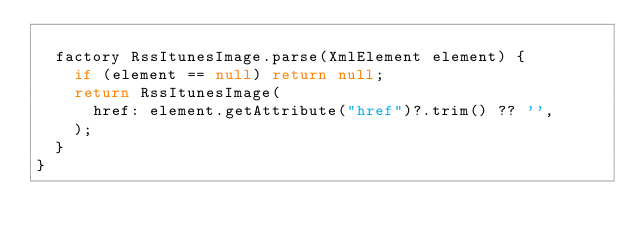<code> <loc_0><loc_0><loc_500><loc_500><_Dart_>
  factory RssItunesImage.parse(XmlElement element) {
    if (element == null) return null;
    return RssItunesImage(
      href: element.getAttribute("href")?.trim() ?? '',
    );
  }
}
</code> 